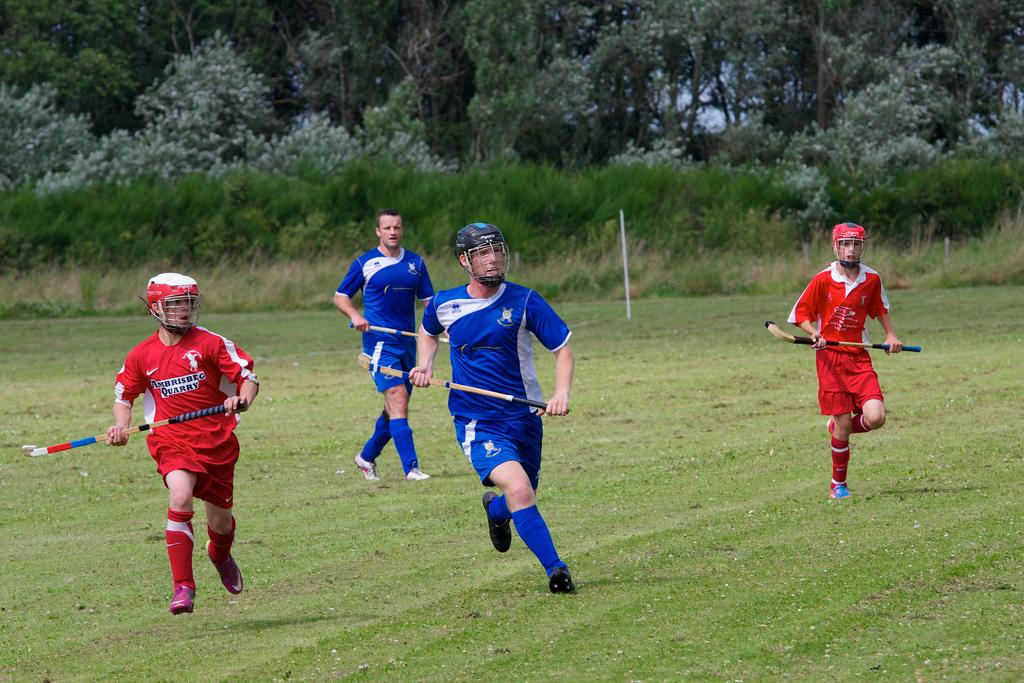Which team is wearing red?
Your answer should be compact. Unanswerable. What shoe brand is represented on the red teams shirts?
Your answer should be compact. Nike. 